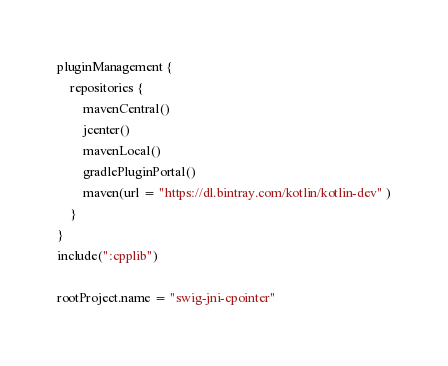Convert code to text. <code><loc_0><loc_0><loc_500><loc_500><_Kotlin_>pluginManagement {
    repositories {
        mavenCentral()
        jcenter()
        mavenLocal()
        gradlePluginPortal()
        maven(url = "https://dl.bintray.com/kotlin/kotlin-dev" )
    }
}
include(":cpplib")

rootProject.name = "swig-jni-cpointer"
</code> 